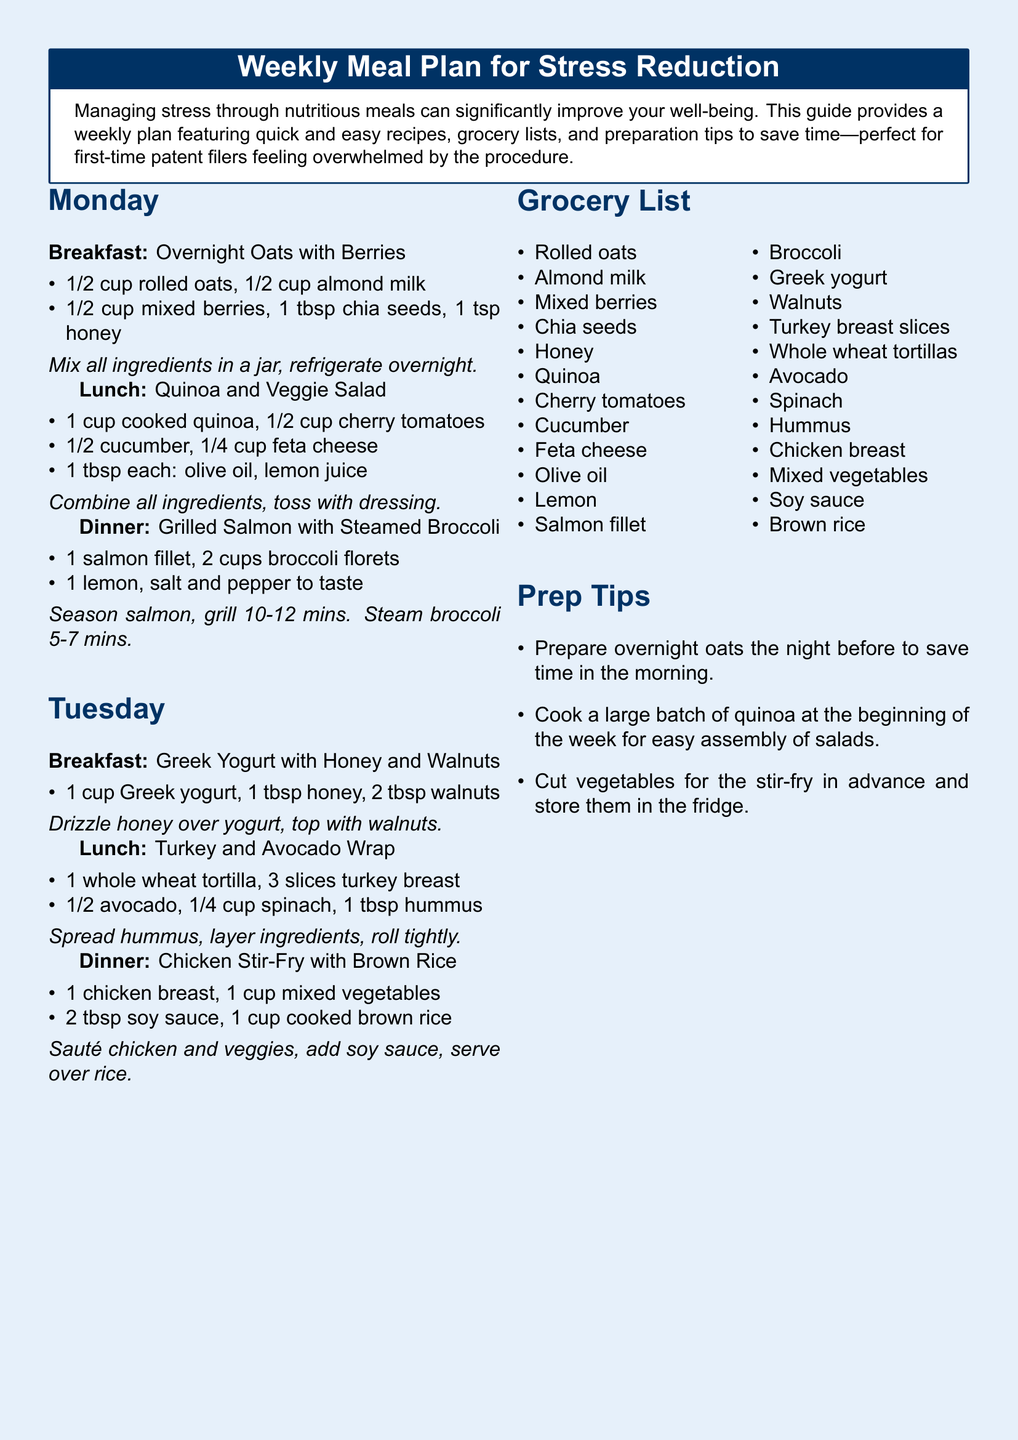What is the title of the document? The title of the document is stated at the top of the meal plan.
Answer: Weekly Meal Plan for Stress Reduction What are the ingredients for the Overnight Oats? The ingredients list for Overnight Oats can be found under Monday's breakfast.
Answer: 1/2 cup rolled oats, 1/2 cup almond milk, 1/2 cup mixed berries, 1 tbsp chia seeds, 1 tsp honey How many cups of broccoli are needed for dinner on Monday? The amount of broccoli is specified in the dinner section for Monday.
Answer: 2 cups What is one tip for meal preparation? The preparation tips section provides strategies to save time.
Answer: Prepare overnight oats the night before Which protein is included in the Tuesday dinner? The dinner section for Tuesday mentions the type of protein used.
Answer: Chicken breast What is the common theme of the meal plan? The overall theme of the meal plan is mentioned in the introduction of the document.
Answer: Stress reduction How many recipes are provided in total? Counting the recipes listed for each meal can answer this question.
Answer: 6 recipes What is a recommended ingredient in the grocery list for snacks? The grocery list features items to be purchased, including potential snack ingredients.
Answer: Greek yogurt 